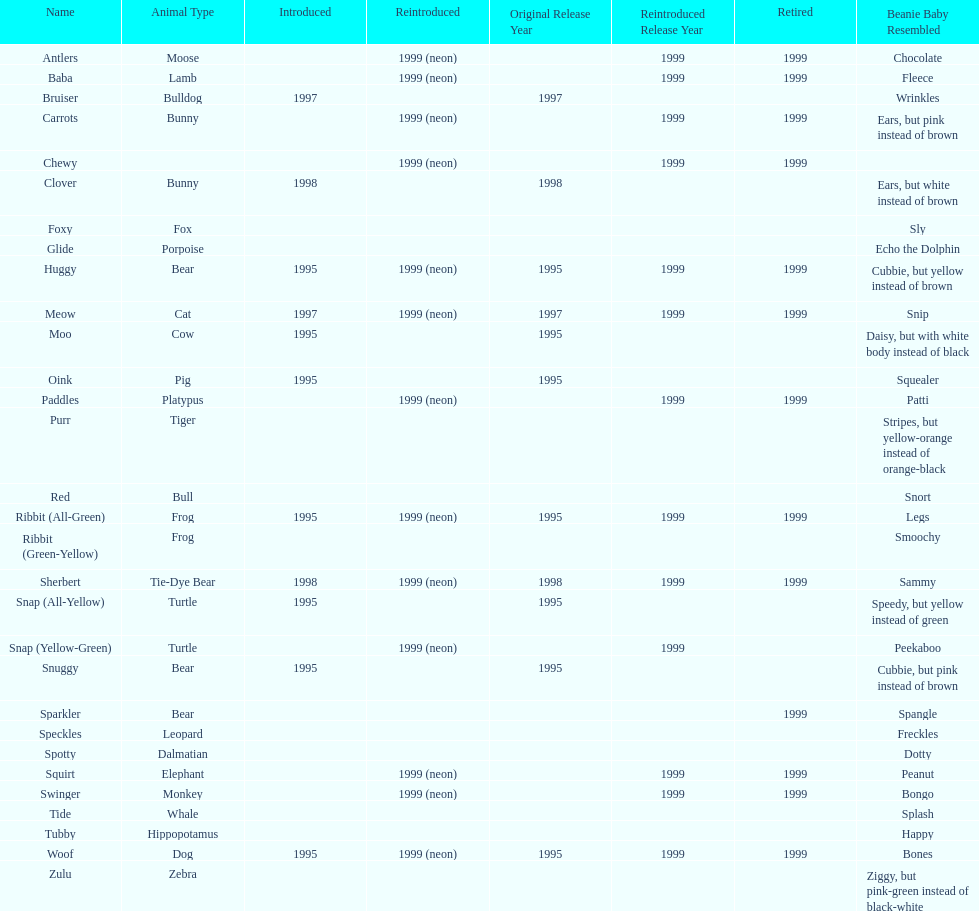Name the only pillow pal that is a dalmatian. Spotty. 